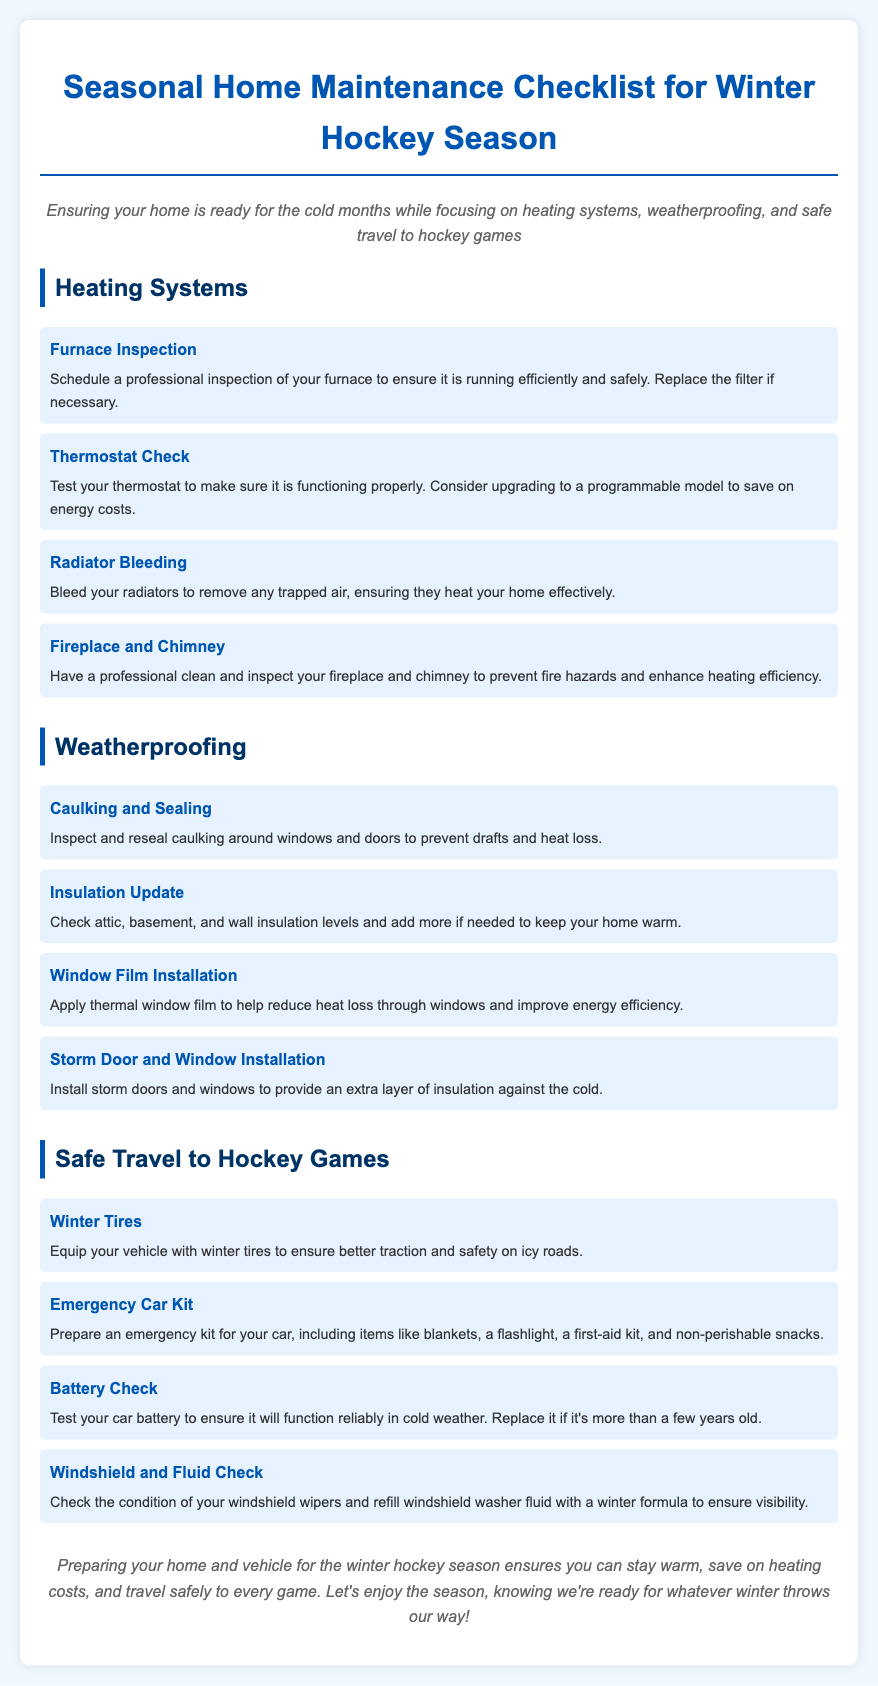What should be inspected for heating efficiency? The document suggests scheduling a professional inspection of the furnace to ensure heating efficiency.
Answer: Furnace What should you check on your car for winter travel? The document recommends testing the battery to ensure it functions reliably in cold weather.
Answer: Battery What type of tires should you equip your vehicle with? The checklist states to equip your vehicle with winter tires for better traction on icy roads.
Answer: Winter tires What is one method to prevent drafts in your home? The document advises inspecting and resealing caulking around windows and doors to prevent drafts.
Answer: Caulking What item is suggested to include in an emergency car kit? The checklist includes blankets as an item you should prepare for your emergency car kit.
Answer: Blankets What benefit does thermal window film provide? The document mentions that thermal window film helps reduce heat loss through windows.
Answer: Reduce heat loss What type of model should you consider upgrading your thermostat to? The document suggests considering upgrading to a programmable thermostat to save on energy costs.
Answer: Programmable model What should be checked for visibility during winter? The checklist recommends checking the condition of windshield wipers and refilling washer fluid for visibility.
Answer: Windshield wipers What should you do with your fireplace before winter? The document states to have a professional clean and inspect your fireplace and chimney to prevent fire hazards.
Answer: Clean and inspect 